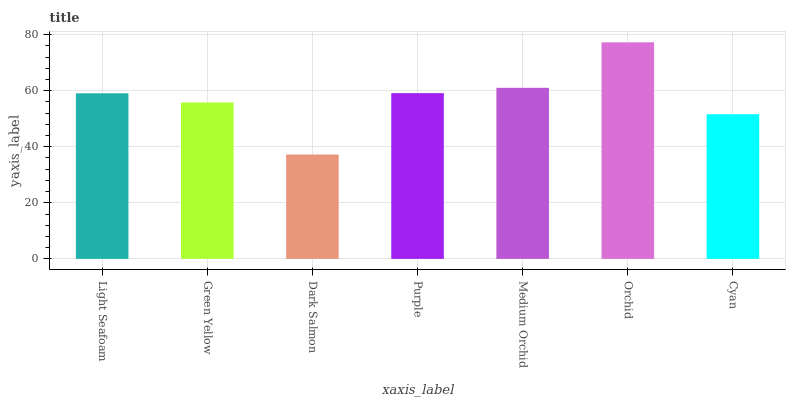Is Dark Salmon the minimum?
Answer yes or no. Yes. Is Orchid the maximum?
Answer yes or no. Yes. Is Green Yellow the minimum?
Answer yes or no. No. Is Green Yellow the maximum?
Answer yes or no. No. Is Light Seafoam greater than Green Yellow?
Answer yes or no. Yes. Is Green Yellow less than Light Seafoam?
Answer yes or no. Yes. Is Green Yellow greater than Light Seafoam?
Answer yes or no. No. Is Light Seafoam less than Green Yellow?
Answer yes or no. No. Is Light Seafoam the high median?
Answer yes or no. Yes. Is Light Seafoam the low median?
Answer yes or no. Yes. Is Orchid the high median?
Answer yes or no. No. Is Cyan the low median?
Answer yes or no. No. 